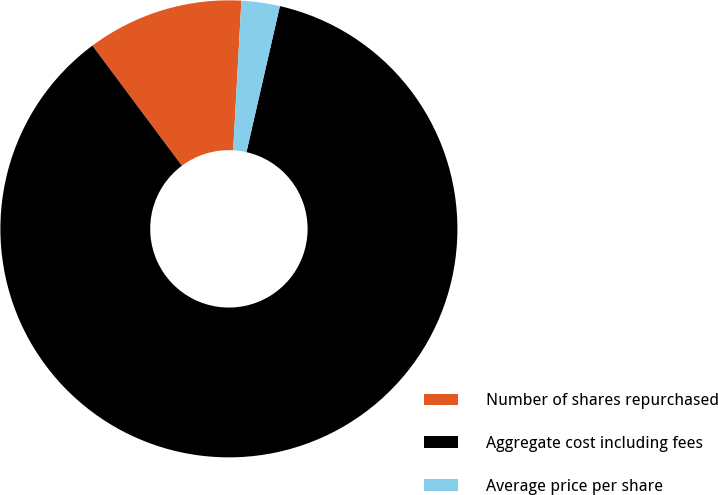<chart> <loc_0><loc_0><loc_500><loc_500><pie_chart><fcel>Number of shares repurchased<fcel>Aggregate cost including fees<fcel>Average price per share<nl><fcel>11.06%<fcel>86.22%<fcel>2.71%<nl></chart> 